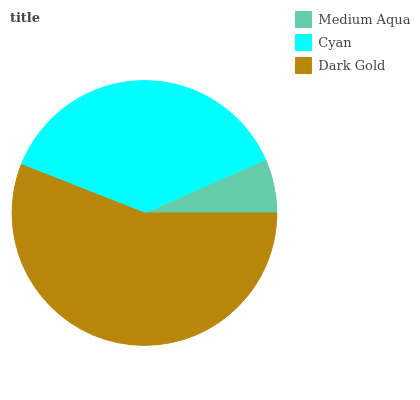Is Medium Aqua the minimum?
Answer yes or no. Yes. Is Dark Gold the maximum?
Answer yes or no. Yes. Is Cyan the minimum?
Answer yes or no. No. Is Cyan the maximum?
Answer yes or no. No. Is Cyan greater than Medium Aqua?
Answer yes or no. Yes. Is Medium Aqua less than Cyan?
Answer yes or no. Yes. Is Medium Aqua greater than Cyan?
Answer yes or no. No. Is Cyan less than Medium Aqua?
Answer yes or no. No. Is Cyan the high median?
Answer yes or no. Yes. Is Cyan the low median?
Answer yes or no. Yes. Is Medium Aqua the high median?
Answer yes or no. No. Is Medium Aqua the low median?
Answer yes or no. No. 